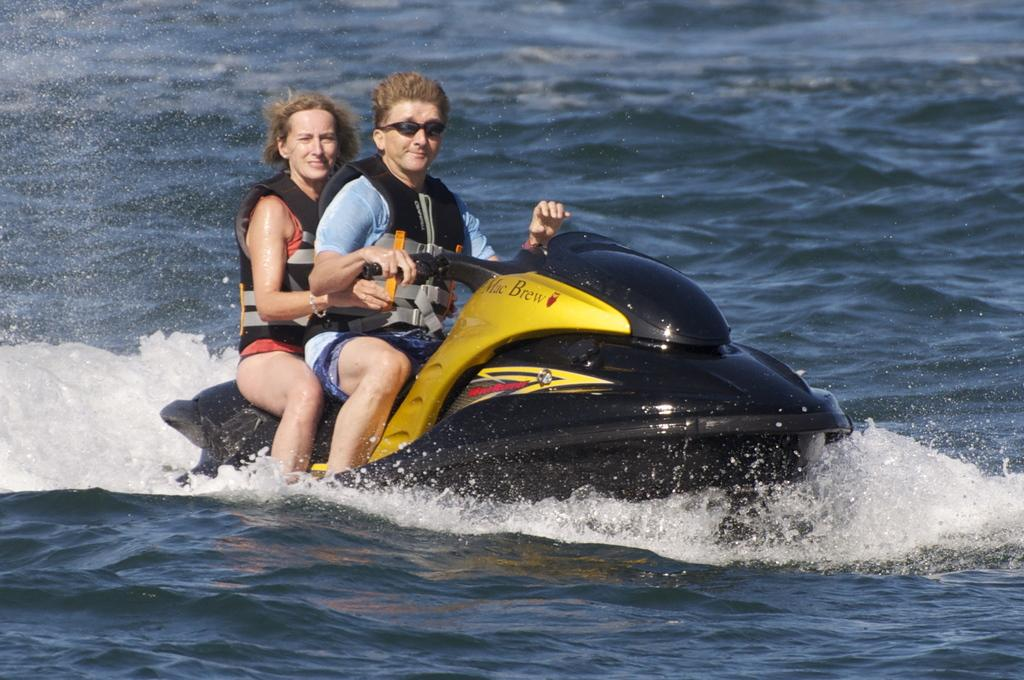Who is present in the image? There is a lady and a man in the image. What are the lady and the man doing in the image? Both the lady and the man are riding on a jet ski. Where is the jet ski located in the image? The jet ski is on the water. What type of writing can be seen on the jet ski in the image? There is no writing visible on the jet ski in the image. How many groups of people are present in the image? There is only one group of people in the image, which consists of the lady and the man. 